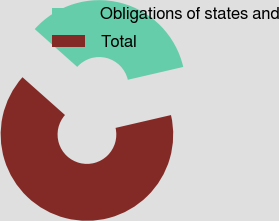Convert chart to OTSL. <chart><loc_0><loc_0><loc_500><loc_500><pie_chart><fcel>Obligations of states and<fcel>Total<nl><fcel>34.81%<fcel>65.19%<nl></chart> 